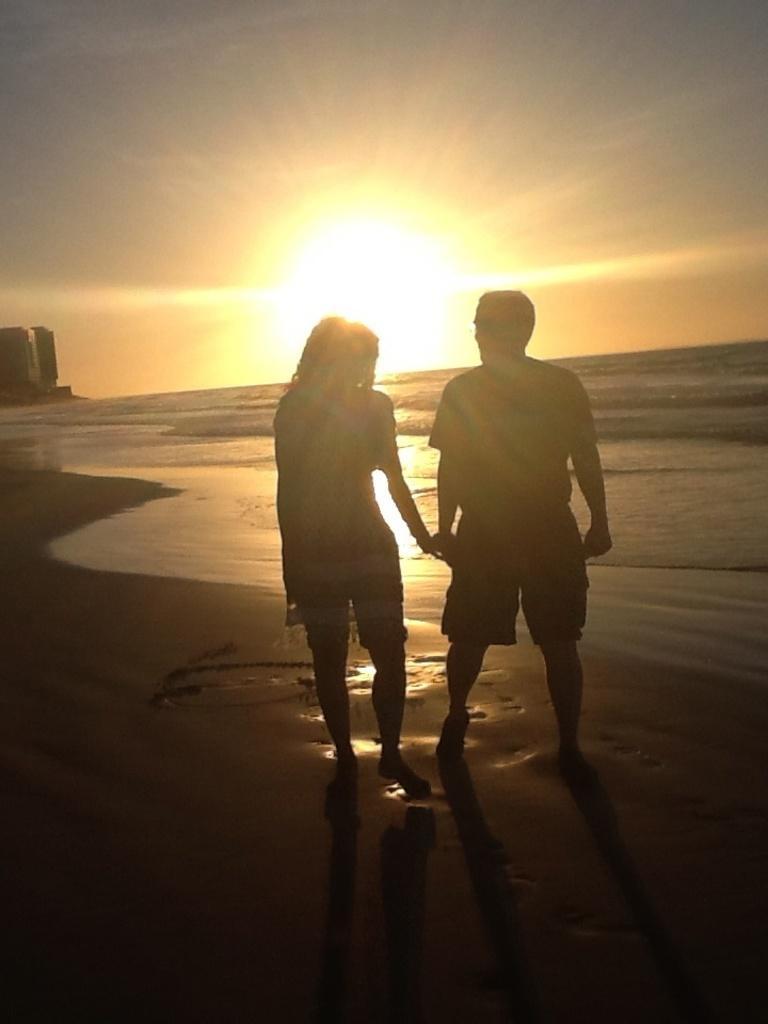Please provide a concise description of this image. At the front of the image there are two people standing on the seashore. In front of them there is a sea. At the top of the image there is a sky with sunlight. 